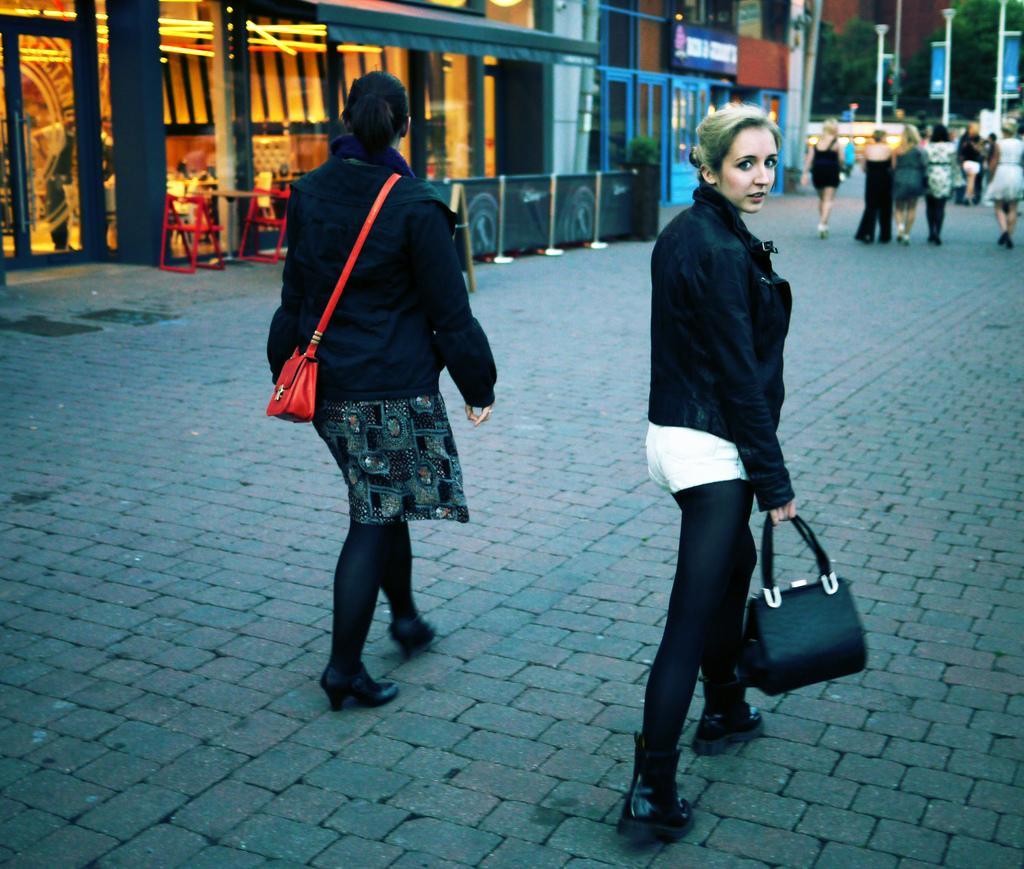Could you give a brief overview of what you see in this image? In this image i can see 2 women walking,The woman on the left side is wearing a red bag and black jacket and the woman on the right side is wearing the black jacket and holding a black bag. In the background i can see people walking, few trees, few poles and few buildings. 